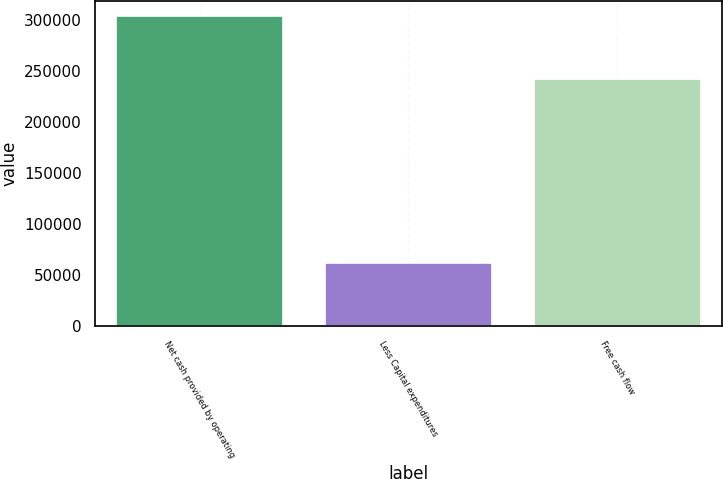Convert chart to OTSL. <chart><loc_0><loc_0><loc_500><loc_500><bar_chart><fcel>Net cash provided by operating<fcel>Less Capital expenditures<fcel>Free cash flow<nl><fcel>303446<fcel>61448<fcel>241998<nl></chart> 